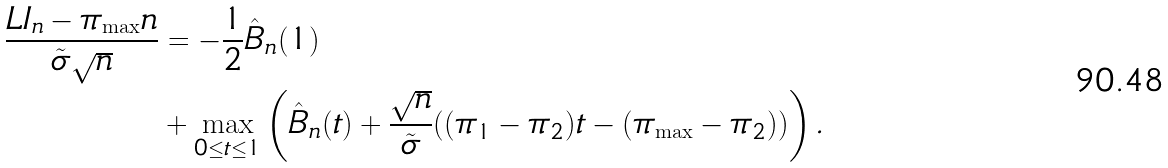Convert formula to latex. <formula><loc_0><loc_0><loc_500><loc_500>\frac { L I _ { n } - \pi _ { \max } n } { \tilde { \sigma } \sqrt { n } } & = - \frac { 1 } { 2 } \hat { B } _ { n } ( 1 ) \\ & + \max _ { 0 \leq t \leq 1 } \left ( \hat { B } _ { n } ( t ) + \frac { \sqrt { n } } { \tilde { \sigma } } ( ( \pi _ { 1 } - \pi _ { 2 } ) t - ( \pi _ { \max } - \pi _ { 2 } ) ) \right ) .</formula> 